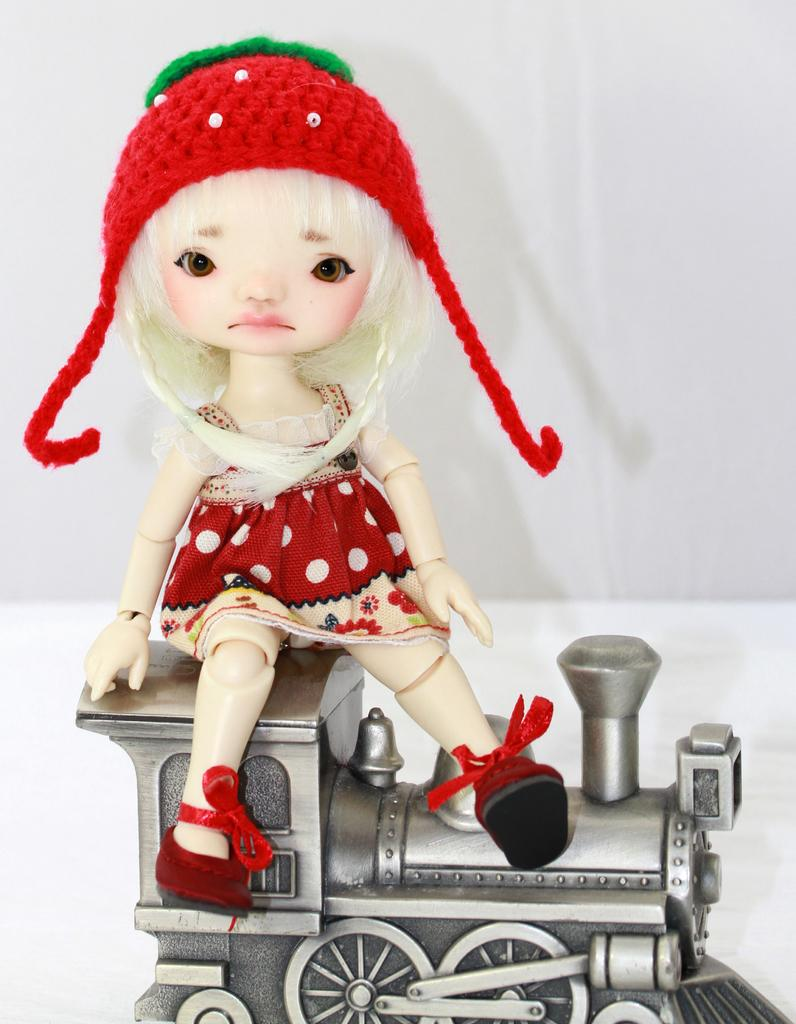What object can be seen in the image? There is a toy in the image. Where is the toy located? The toy is on a surface. How does the toy transport people in the image? The toy does not transport people in the image, as it is not a mode of transportation. 